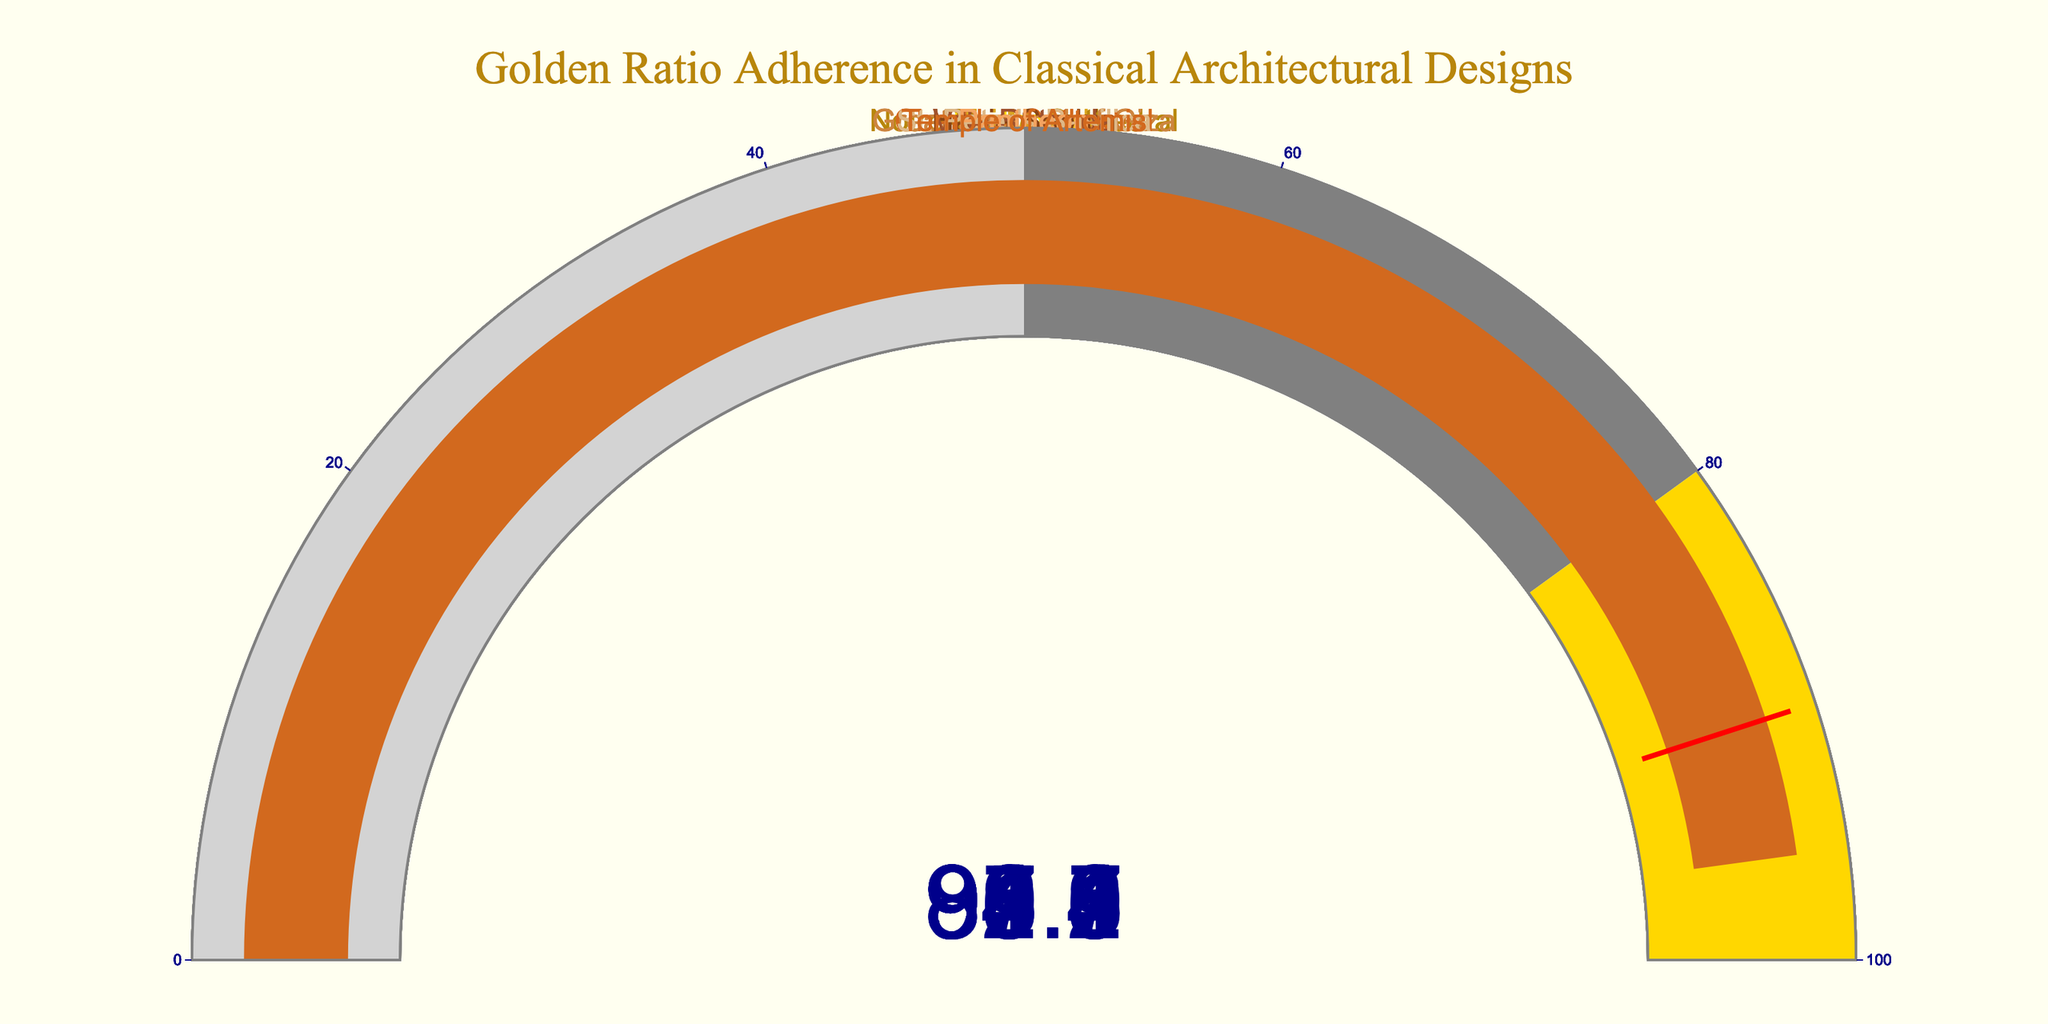What's the adherence percentage of the Parthenon? The gauge chart shows one number in the middle of each gauge that represents the adherence percentage. The Parthenon's gauge shows a percentage value.
Answer: 96.5 Which structure has the lowest adherence to the golden ratio? By examining each gauge for the smallest percentage, we find that Hagia Sophia has the lowest adherence percentage among the displayed values.
Answer: Hagia Sophia What is the average adherence percentage of all structures? To find the average: sum all percentages and then divide by the number of structures. Sum: 96.5 + 91.2 + 88.7 + 94.8 + 90.3 + 87.9 + 93.6 + 89.1 + 92.4 + 95.7 = 920.2. Average: 920.2 / 10 = 92.02.
Answer: 92.02 How many structures have an adherence percentage above 90%? Count the number of gauges with percentages greater than 90. Those are the Parthenon, Taj Mahal, Great Pyramid of Giza, Villa Rotonda, Pantheon, and Temple of Artemis. This makes a total of 6 structures.
Answer: 6 Which two structures have the closest adherence percentages? By comparing the differences between each pair’s adherence percentages, the closest values are Notre-Dame Cathedral (88.7) and Hagia Sophia (87.9) with a difference of 0.8.
Answer: Notre-Dame Cathedral and Hagia Sophia What's the difference in adherence percentage between the Temple of Artemis and St. Peter's Basilica? Subtract the adherence percentage of St. Peter's Basilica from that of the Temple of Artemis. 95.7 - 89.1 = 6.6.
Answer: 6.6 Which structure displaying a percentage on a golden-colored bar? The colors and the areas they represent can be determined from the legend within the gauge design. A detailed look reveals that the Parthenon shows a percentage within the golden-colored bar.
Answer: Parthenon 